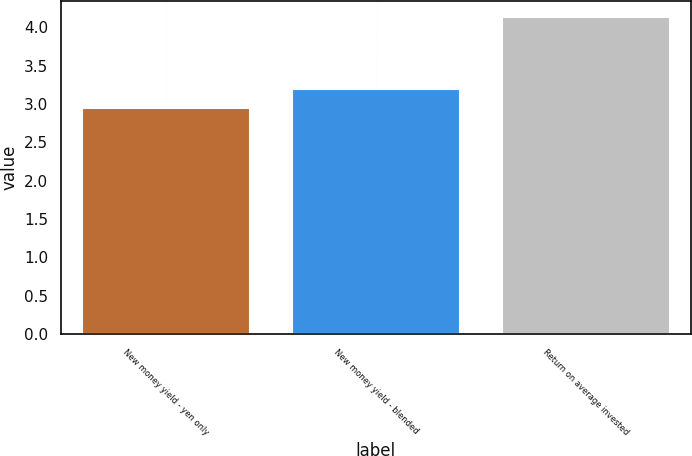<chart> <loc_0><loc_0><loc_500><loc_500><bar_chart><fcel>New money yield - yen only<fcel>New money yield - blended<fcel>Return on average invested<nl><fcel>2.95<fcel>3.19<fcel>4.14<nl></chart> 